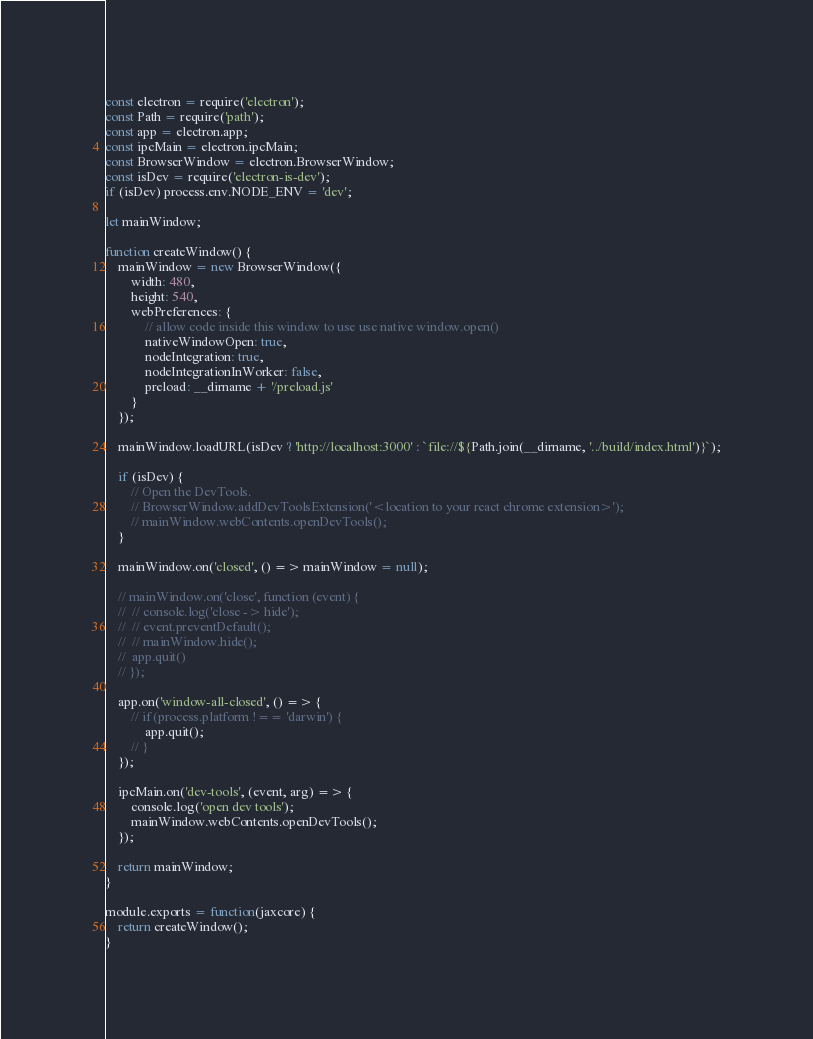<code> <loc_0><loc_0><loc_500><loc_500><_JavaScript_>const electron = require('electron');
const Path = require('path');
const app = electron.app;
const ipcMain = electron.ipcMain;
const BrowserWindow = electron.BrowserWindow;
const isDev = require('electron-is-dev');
if (isDev) process.env.NODE_ENV = 'dev';

let mainWindow;

function createWindow() {
	mainWindow = new BrowserWindow({
		width: 480,
		height: 540,
		webPreferences: {
			// allow code inside this window to use use native window.open()
			nativeWindowOpen: true,
			nodeIntegration: true,
			nodeIntegrationInWorker: false,
			preload: __dirname + '/preload.js'
		}
	});
	
	mainWindow.loadURL(isDev ? 'http://localhost:3000' : `file://${Path.join(__dirname, '../build/index.html')}`);
	
	if (isDev) {
		// Open the DevTools.
		// BrowserWindow.addDevToolsExtension('<location to your react chrome extension>');
		// mainWindow.webContents.openDevTools();
	}
	
	mainWindow.on('closed', () => mainWindow = null);
	
	// mainWindow.on('close', function (event) {
	// 	// console.log('close -> hide');
	// 	// event.preventDefault();
	// 	// mainWindow.hide();
	// 	app.quit()
	// });
	
	app.on('window-all-closed', () => {
		// if (process.platform !== 'darwin') {
			app.quit();
		// }
	});
	
	ipcMain.on('dev-tools', (event, arg) => {
		console.log('open dev tools');
		mainWindow.webContents.openDevTools();
	});
	
	return mainWindow;
}

module.exports = function(jaxcore) {
	return createWindow();
}</code> 